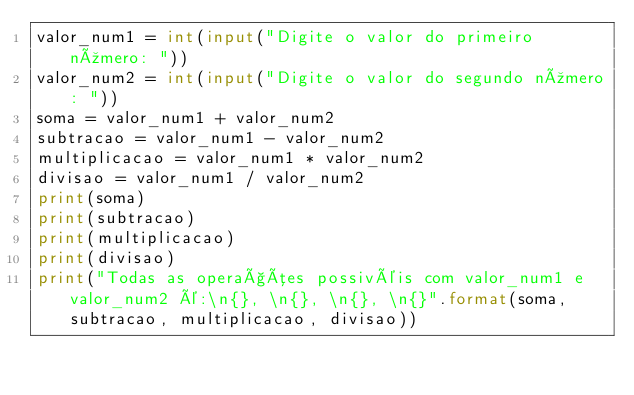<code> <loc_0><loc_0><loc_500><loc_500><_Python_>valor_num1 = int(input("Digite o valor do primeiro número: "))
valor_num2 = int(input("Digite o valor do segundo número: "))
soma = valor_num1 + valor_num2
subtracao = valor_num1 - valor_num2
multiplicacao = valor_num1 * valor_num2
divisao = valor_num1 / valor_num2
print(soma)
print(subtracao)
print(multiplicacao)
print(divisao)
print("Todas as operações possivéis com valor_num1 e valor_num2 é:\n{}, \n{}, \n{}, \n{}".format(soma, subtracao, multiplicacao, divisao))</code> 